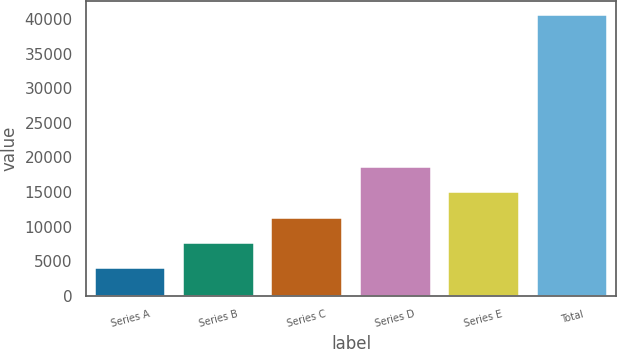Convert chart. <chart><loc_0><loc_0><loc_500><loc_500><bar_chart><fcel>Series A<fcel>Series B<fcel>Series C<fcel>Series D<fcel>Series E<fcel>Total<nl><fcel>4000<fcel>7650<fcel>11300<fcel>18600<fcel>14950<fcel>40500<nl></chart> 